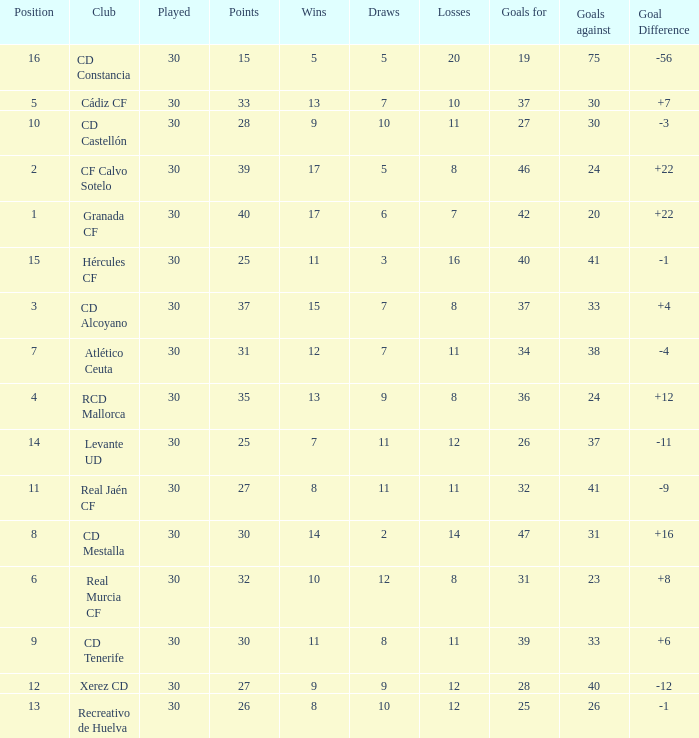Which player, belonging to the atlético ceuta club, has experienced fewer than 11 losses? None. 